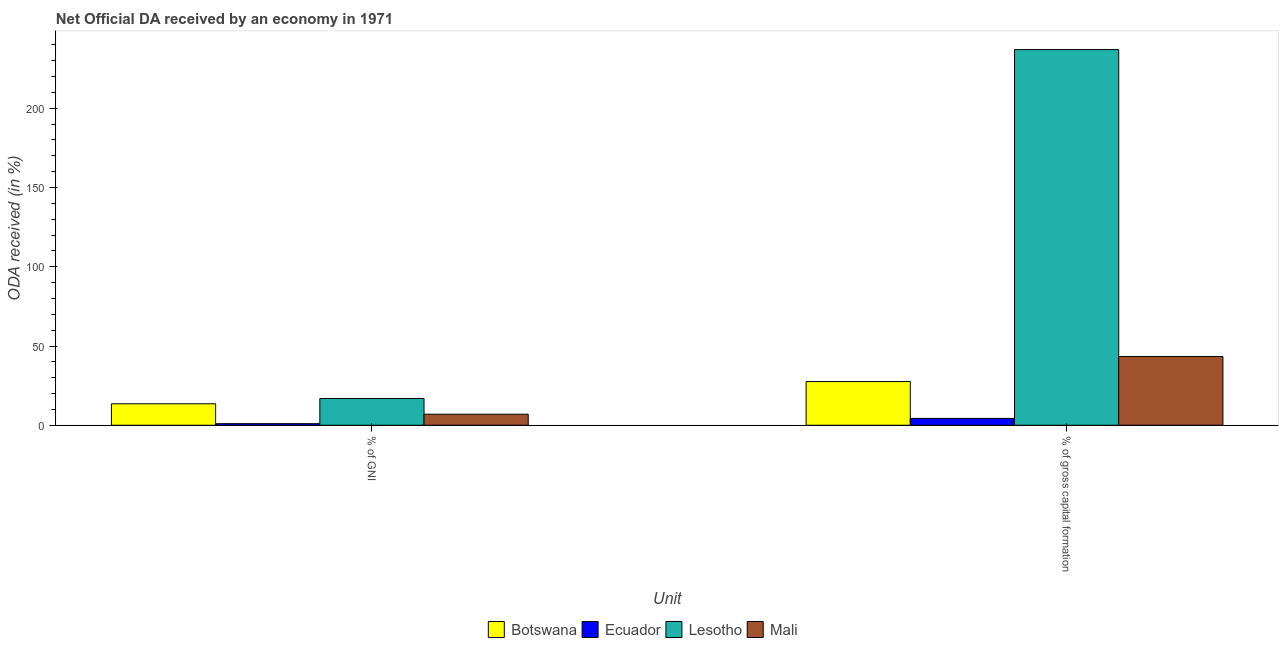How many different coloured bars are there?
Your response must be concise. 4. How many groups of bars are there?
Keep it short and to the point. 2. Are the number of bars per tick equal to the number of legend labels?
Make the answer very short. Yes. Are the number of bars on each tick of the X-axis equal?
Provide a succinct answer. Yes. How many bars are there on the 2nd tick from the right?
Provide a short and direct response. 4. What is the label of the 1st group of bars from the left?
Ensure brevity in your answer.  % of GNI. What is the oda received as percentage of gni in Botswana?
Your answer should be compact. 13.53. Across all countries, what is the maximum oda received as percentage of gross capital formation?
Offer a very short reply. 237.02. Across all countries, what is the minimum oda received as percentage of gross capital formation?
Provide a succinct answer. 4.32. In which country was the oda received as percentage of gni maximum?
Provide a short and direct response. Lesotho. In which country was the oda received as percentage of gross capital formation minimum?
Provide a succinct answer. Ecuador. What is the total oda received as percentage of gross capital formation in the graph?
Ensure brevity in your answer.  312.25. What is the difference between the oda received as percentage of gni in Lesotho and that in Mali?
Give a very brief answer. 9.92. What is the difference between the oda received as percentage of gross capital formation in Ecuador and the oda received as percentage of gni in Botswana?
Your answer should be compact. -9.21. What is the average oda received as percentage of gross capital formation per country?
Ensure brevity in your answer.  78.06. What is the difference between the oda received as percentage of gni and oda received as percentage of gross capital formation in Lesotho?
Your response must be concise. -220.14. In how many countries, is the oda received as percentage of gross capital formation greater than 210 %?
Ensure brevity in your answer.  1. What is the ratio of the oda received as percentage of gross capital formation in Ecuador to that in Lesotho?
Provide a short and direct response. 0.02. Is the oda received as percentage of gni in Mali less than that in Lesotho?
Provide a succinct answer. Yes. What does the 2nd bar from the left in % of GNI represents?
Your answer should be very brief. Ecuador. What does the 2nd bar from the right in % of gross capital formation represents?
Give a very brief answer. Lesotho. Are all the bars in the graph horizontal?
Provide a short and direct response. No. Does the graph contain any zero values?
Keep it short and to the point. No. Does the graph contain grids?
Keep it short and to the point. No. How many legend labels are there?
Offer a very short reply. 4. How are the legend labels stacked?
Your answer should be compact. Horizontal. What is the title of the graph?
Ensure brevity in your answer.  Net Official DA received by an economy in 1971. Does "Malawi" appear as one of the legend labels in the graph?
Your answer should be compact. No. What is the label or title of the X-axis?
Ensure brevity in your answer.  Unit. What is the label or title of the Y-axis?
Offer a terse response. ODA received (in %). What is the ODA received (in %) of Botswana in % of GNI?
Make the answer very short. 13.53. What is the ODA received (in %) in Ecuador in % of GNI?
Offer a very short reply. 0.98. What is the ODA received (in %) in Lesotho in % of GNI?
Make the answer very short. 16.88. What is the ODA received (in %) of Mali in % of GNI?
Your answer should be compact. 6.96. What is the ODA received (in %) of Botswana in % of gross capital formation?
Give a very brief answer. 27.56. What is the ODA received (in %) of Ecuador in % of gross capital formation?
Your answer should be very brief. 4.32. What is the ODA received (in %) in Lesotho in % of gross capital formation?
Keep it short and to the point. 237.02. What is the ODA received (in %) in Mali in % of gross capital formation?
Provide a succinct answer. 43.35. Across all Unit, what is the maximum ODA received (in %) of Botswana?
Your answer should be very brief. 27.56. Across all Unit, what is the maximum ODA received (in %) of Ecuador?
Provide a succinct answer. 4.32. Across all Unit, what is the maximum ODA received (in %) of Lesotho?
Your answer should be very brief. 237.02. Across all Unit, what is the maximum ODA received (in %) of Mali?
Keep it short and to the point. 43.35. Across all Unit, what is the minimum ODA received (in %) in Botswana?
Ensure brevity in your answer.  13.53. Across all Unit, what is the minimum ODA received (in %) in Ecuador?
Offer a terse response. 0.98. Across all Unit, what is the minimum ODA received (in %) in Lesotho?
Offer a very short reply. 16.88. Across all Unit, what is the minimum ODA received (in %) of Mali?
Give a very brief answer. 6.96. What is the total ODA received (in %) in Botswana in the graph?
Make the answer very short. 41.1. What is the total ODA received (in %) of Ecuador in the graph?
Provide a short and direct response. 5.3. What is the total ODA received (in %) of Lesotho in the graph?
Ensure brevity in your answer.  253.9. What is the total ODA received (in %) of Mali in the graph?
Offer a terse response. 50.31. What is the difference between the ODA received (in %) in Botswana in % of GNI and that in % of gross capital formation?
Offer a very short reply. -14.03. What is the difference between the ODA received (in %) of Ecuador in % of GNI and that in % of gross capital formation?
Make the answer very short. -3.34. What is the difference between the ODA received (in %) in Lesotho in % of GNI and that in % of gross capital formation?
Your answer should be very brief. -220.14. What is the difference between the ODA received (in %) in Mali in % of GNI and that in % of gross capital formation?
Your answer should be compact. -36.38. What is the difference between the ODA received (in %) in Botswana in % of GNI and the ODA received (in %) in Ecuador in % of gross capital formation?
Give a very brief answer. 9.21. What is the difference between the ODA received (in %) in Botswana in % of GNI and the ODA received (in %) in Lesotho in % of gross capital formation?
Your answer should be compact. -223.49. What is the difference between the ODA received (in %) of Botswana in % of GNI and the ODA received (in %) of Mali in % of gross capital formation?
Make the answer very short. -29.81. What is the difference between the ODA received (in %) of Ecuador in % of GNI and the ODA received (in %) of Lesotho in % of gross capital formation?
Ensure brevity in your answer.  -236.04. What is the difference between the ODA received (in %) of Ecuador in % of GNI and the ODA received (in %) of Mali in % of gross capital formation?
Offer a terse response. -42.37. What is the difference between the ODA received (in %) in Lesotho in % of GNI and the ODA received (in %) in Mali in % of gross capital formation?
Your response must be concise. -26.46. What is the average ODA received (in %) of Botswana per Unit?
Your response must be concise. 20.55. What is the average ODA received (in %) of Ecuador per Unit?
Make the answer very short. 2.65. What is the average ODA received (in %) in Lesotho per Unit?
Your response must be concise. 126.95. What is the average ODA received (in %) of Mali per Unit?
Make the answer very short. 25.16. What is the difference between the ODA received (in %) of Botswana and ODA received (in %) of Ecuador in % of GNI?
Offer a very short reply. 12.55. What is the difference between the ODA received (in %) in Botswana and ODA received (in %) in Lesotho in % of GNI?
Provide a succinct answer. -3.35. What is the difference between the ODA received (in %) of Botswana and ODA received (in %) of Mali in % of GNI?
Provide a short and direct response. 6.57. What is the difference between the ODA received (in %) of Ecuador and ODA received (in %) of Lesotho in % of GNI?
Give a very brief answer. -15.9. What is the difference between the ODA received (in %) of Ecuador and ODA received (in %) of Mali in % of GNI?
Keep it short and to the point. -5.98. What is the difference between the ODA received (in %) in Lesotho and ODA received (in %) in Mali in % of GNI?
Offer a terse response. 9.92. What is the difference between the ODA received (in %) of Botswana and ODA received (in %) of Ecuador in % of gross capital formation?
Make the answer very short. 23.24. What is the difference between the ODA received (in %) in Botswana and ODA received (in %) in Lesotho in % of gross capital formation?
Your answer should be compact. -209.46. What is the difference between the ODA received (in %) in Botswana and ODA received (in %) in Mali in % of gross capital formation?
Ensure brevity in your answer.  -15.78. What is the difference between the ODA received (in %) of Ecuador and ODA received (in %) of Lesotho in % of gross capital formation?
Your answer should be compact. -232.7. What is the difference between the ODA received (in %) of Ecuador and ODA received (in %) of Mali in % of gross capital formation?
Provide a succinct answer. -39.03. What is the difference between the ODA received (in %) of Lesotho and ODA received (in %) of Mali in % of gross capital formation?
Your response must be concise. 193.68. What is the ratio of the ODA received (in %) in Botswana in % of GNI to that in % of gross capital formation?
Ensure brevity in your answer.  0.49. What is the ratio of the ODA received (in %) in Ecuador in % of GNI to that in % of gross capital formation?
Ensure brevity in your answer.  0.23. What is the ratio of the ODA received (in %) of Lesotho in % of GNI to that in % of gross capital formation?
Offer a terse response. 0.07. What is the ratio of the ODA received (in %) in Mali in % of GNI to that in % of gross capital formation?
Give a very brief answer. 0.16. What is the difference between the highest and the second highest ODA received (in %) of Botswana?
Your response must be concise. 14.03. What is the difference between the highest and the second highest ODA received (in %) of Ecuador?
Your answer should be compact. 3.34. What is the difference between the highest and the second highest ODA received (in %) of Lesotho?
Ensure brevity in your answer.  220.14. What is the difference between the highest and the second highest ODA received (in %) of Mali?
Your answer should be very brief. 36.38. What is the difference between the highest and the lowest ODA received (in %) of Botswana?
Keep it short and to the point. 14.03. What is the difference between the highest and the lowest ODA received (in %) of Ecuador?
Offer a terse response. 3.34. What is the difference between the highest and the lowest ODA received (in %) of Lesotho?
Offer a very short reply. 220.14. What is the difference between the highest and the lowest ODA received (in %) in Mali?
Provide a succinct answer. 36.38. 